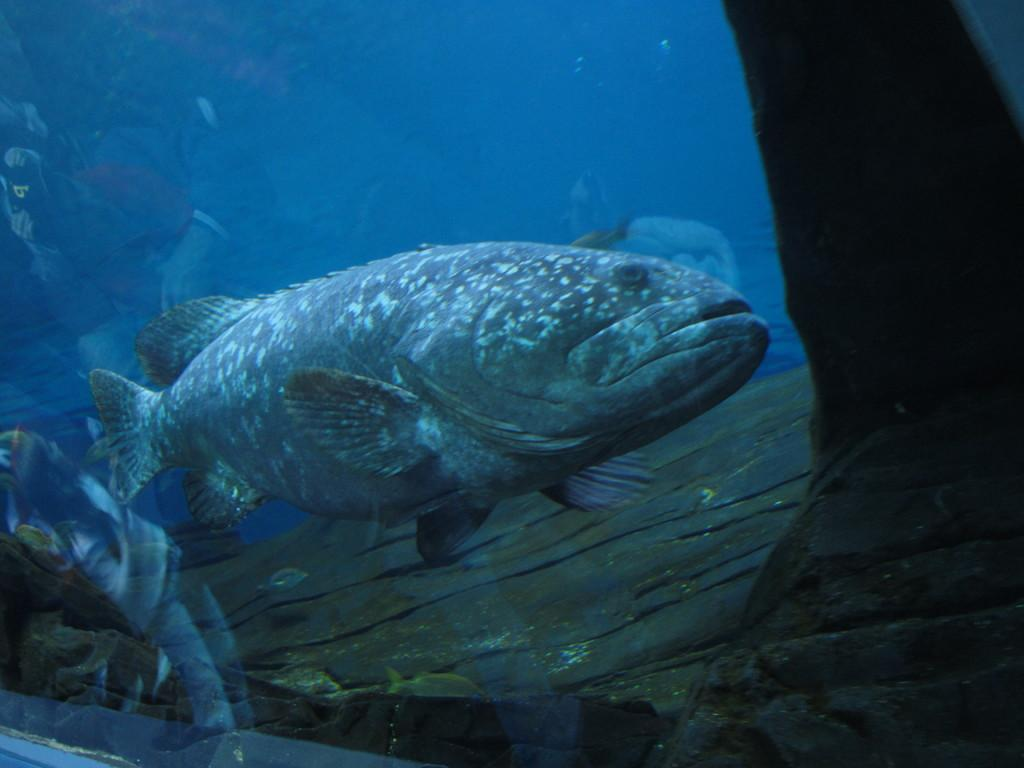What type of animal is in the image? There is a fish in the image. Where is the fish located? The fish is in water. How is the water containing the fish protected or enclosed? The water is covered with a glass. How many books are stacked on the fish's birthday cake in the image? There are no books or birthday cake present in the image; it features a fish in water covered by a glass. 